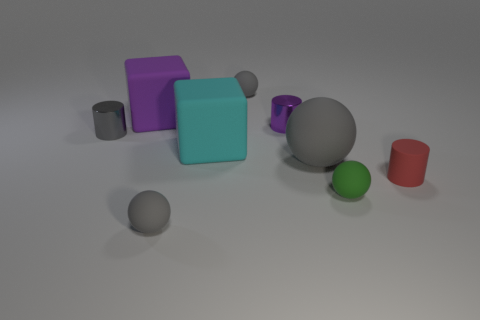Subtract all cyan cubes. How many gray spheres are left? 3 Add 1 large rubber objects. How many objects exist? 10 Subtract all cylinders. How many objects are left? 6 Subtract all green metal things. Subtract all purple metal cylinders. How many objects are left? 8 Add 4 purple matte things. How many purple matte things are left? 5 Add 5 green matte blocks. How many green matte blocks exist? 5 Subtract 0 brown cubes. How many objects are left? 9 